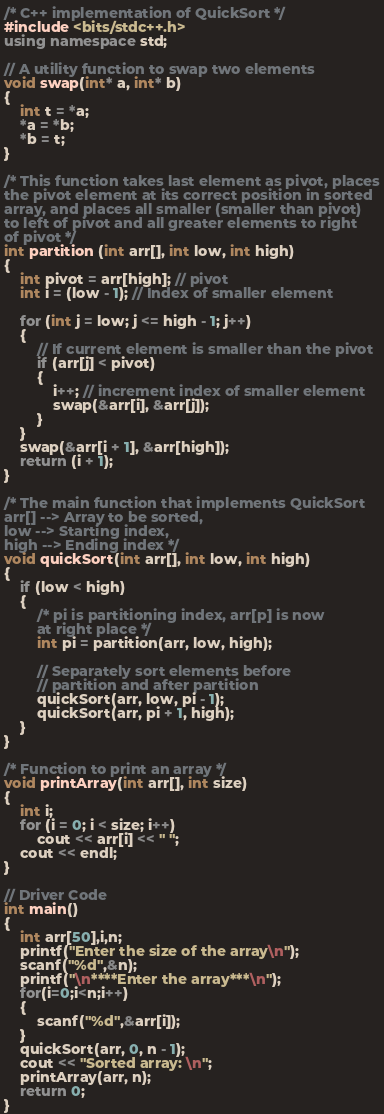Convert code to text. <code><loc_0><loc_0><loc_500><loc_500><_C++_>/* C++ implementation of QuickSort */
#include <bits/stdc++.h>
using namespace std;

// A utility function to swap two elements
void swap(int* a, int* b)
{
    int t = *a;
    *a = *b;
    *b = t;
}

/* This function takes last element as pivot, places
the pivot element at its correct position in sorted
array, and places all smaller (smaller than pivot)
to left of pivot and all greater elements to right
of pivot */
int partition (int arr[], int low, int high)
{
    int pivot = arr[high]; // pivot
    int i = (low - 1); // Index of smaller element

    for (int j = low; j <= high - 1; j++)
    {
        // If current element is smaller than the pivot
        if (arr[j] < pivot)
        {
            i++; // increment index of smaller element
            swap(&arr[i], &arr[j]);
        }
    }
    swap(&arr[i + 1], &arr[high]);
    return (i + 1);
}

/* The main function that implements QuickSort
arr[] --> Array to be sorted,
low --> Starting index,
high --> Ending index */
void quickSort(int arr[], int low, int high)
{
    if (low < high)
    {
        /* pi is partitioning index, arr[p] is now
        at right place */
        int pi = partition(arr, low, high);

        // Separately sort elements before
        // partition and after partition
        quickSort(arr, low, pi - 1);
        quickSort(arr, pi + 1, high);
    }
}

/* Function to print an array */
void printArray(int arr[], int size)
{
    int i;
    for (i = 0; i < size; i++)
        cout << arr[i] << " ";
    cout << endl;
}

// Driver Code
int main()
{
    int arr[50],i,n;
    printf("Enter the size of the array\n");
    scanf("%d",&n);
    printf("\n****Enter the array***\n");
    for(i=0;i<n;i++)
    {
        scanf("%d",&arr[i]);
    }
    quickSort(arr, 0, n - 1);
    cout << "Sorted array: \n";
    printArray(arr, n);
    return 0;
}
</code> 